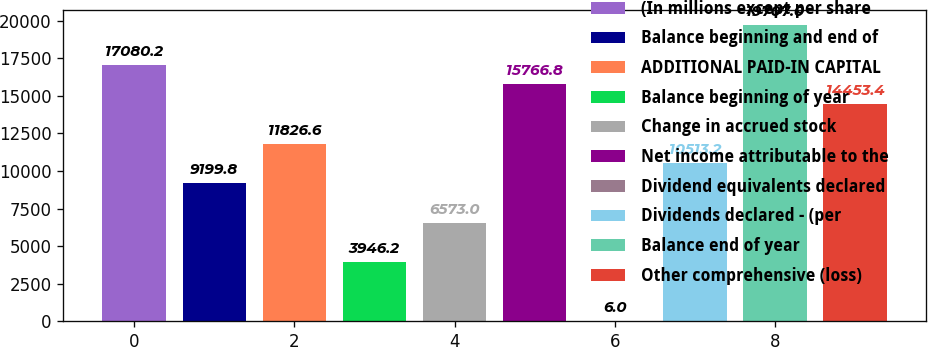<chart> <loc_0><loc_0><loc_500><loc_500><bar_chart><fcel>(In millions except per share<fcel>Balance beginning and end of<fcel>ADDITIONAL PAID-IN CAPITAL<fcel>Balance beginning of year<fcel>Change in accrued stock<fcel>Net income attributable to the<fcel>Dividend equivalents declared<fcel>Dividends declared - (per<fcel>Balance end of year<fcel>Other comprehensive (loss)<nl><fcel>17080.2<fcel>9199.8<fcel>11826.6<fcel>3946.2<fcel>6573<fcel>15766.8<fcel>6<fcel>10513.2<fcel>19707<fcel>14453.4<nl></chart> 